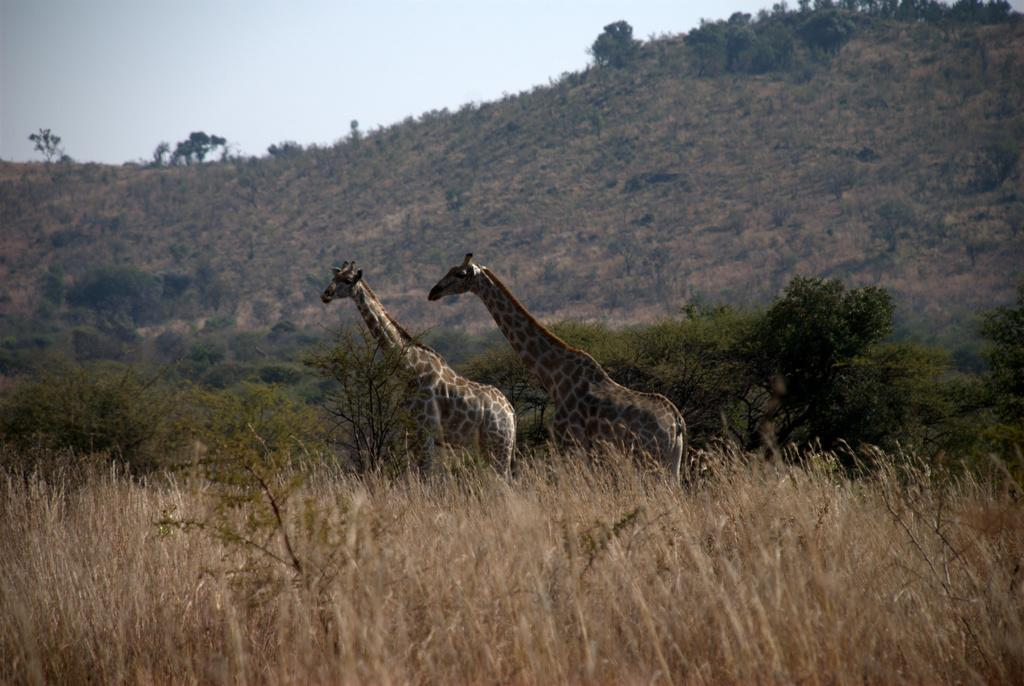How many giraffes are in the image? There are two giraffes in the image. What can be seen in the background of the image? There are plants and a mountain in the background of the image. What is the condition of the sky in the image? The sky is clear in the background of the image. What type of humor can be seen in the image? There is no humor present in the image; it features two giraffes, plants, a mountain, and a clear sky. How many steps are visible in the image? There are no steps visible in the image. 